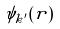<formula> <loc_0><loc_0><loc_500><loc_500>\psi _ { k ^ { \prime } } ( r )</formula> 